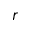<formula> <loc_0><loc_0><loc_500><loc_500>r</formula> 